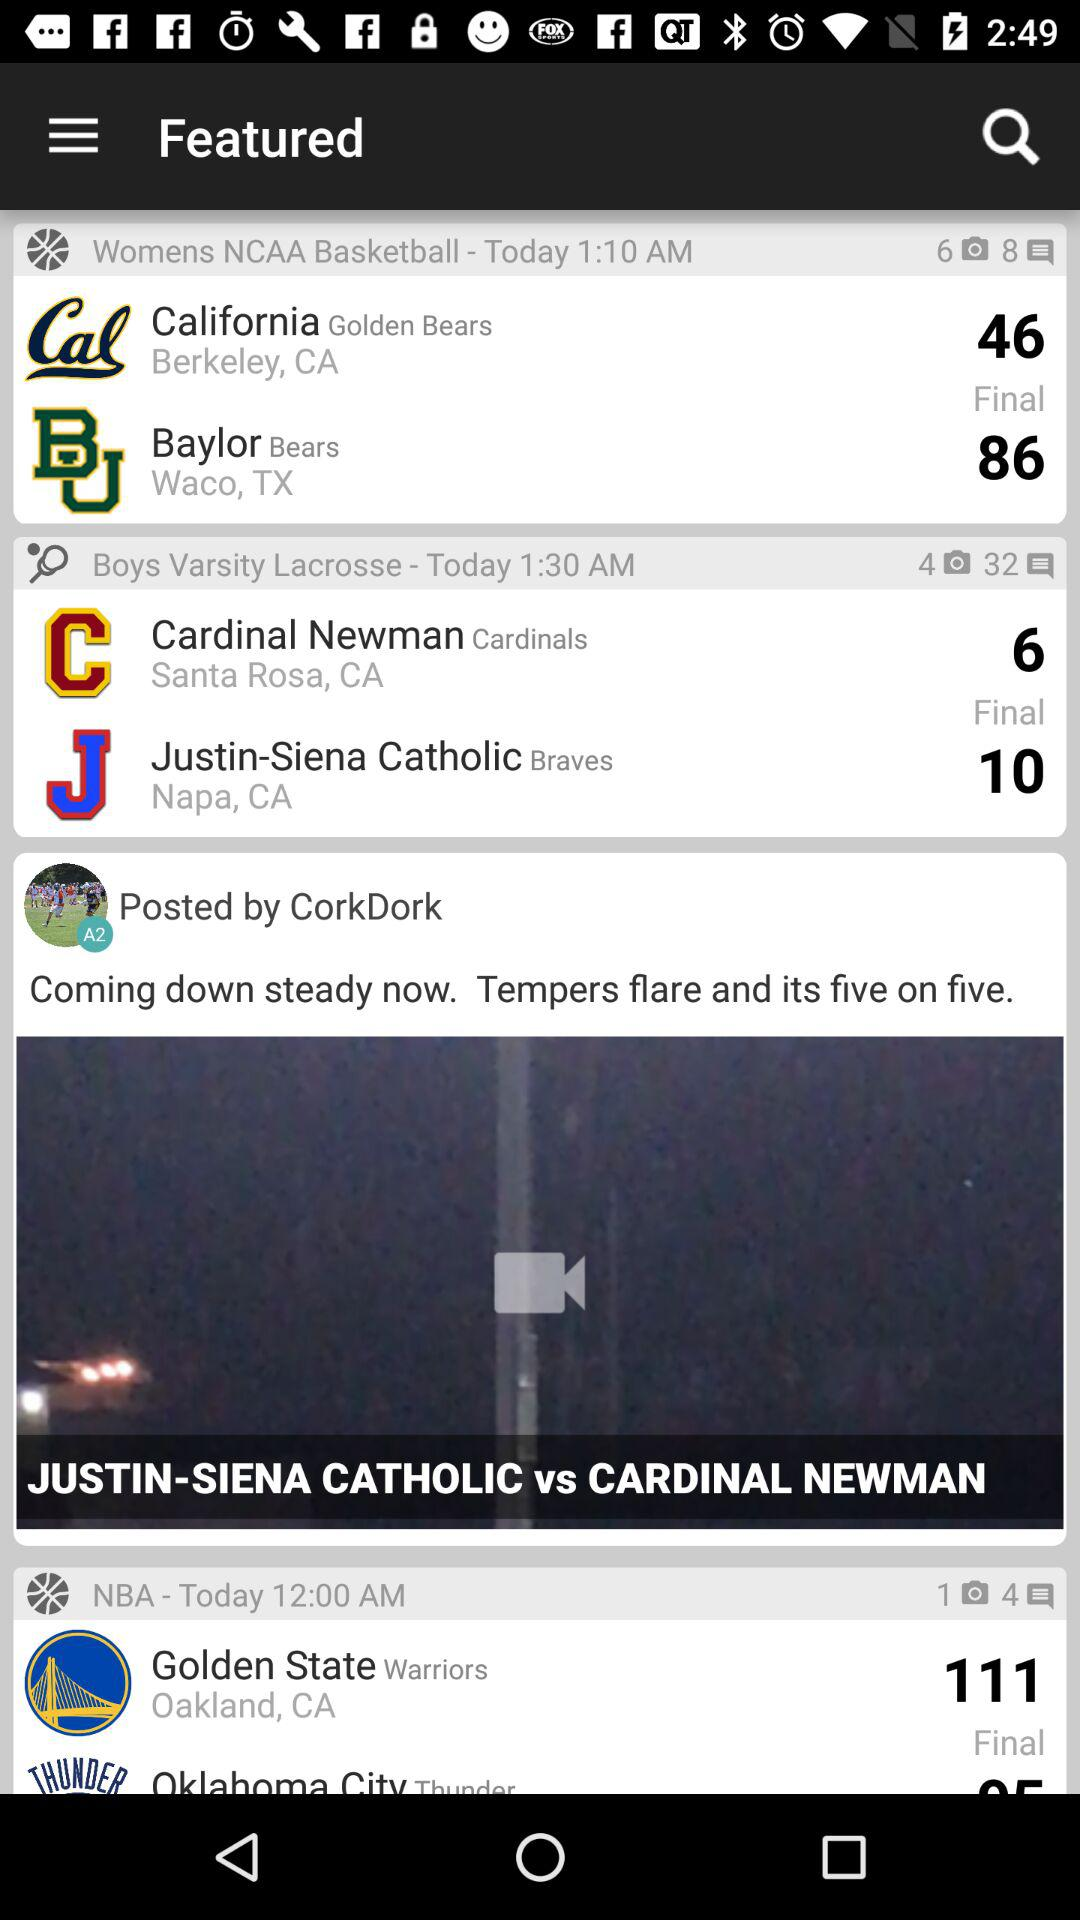What is the time of the "Womens NCAA Basketball" match? The time of the match is 1:10 AM. 